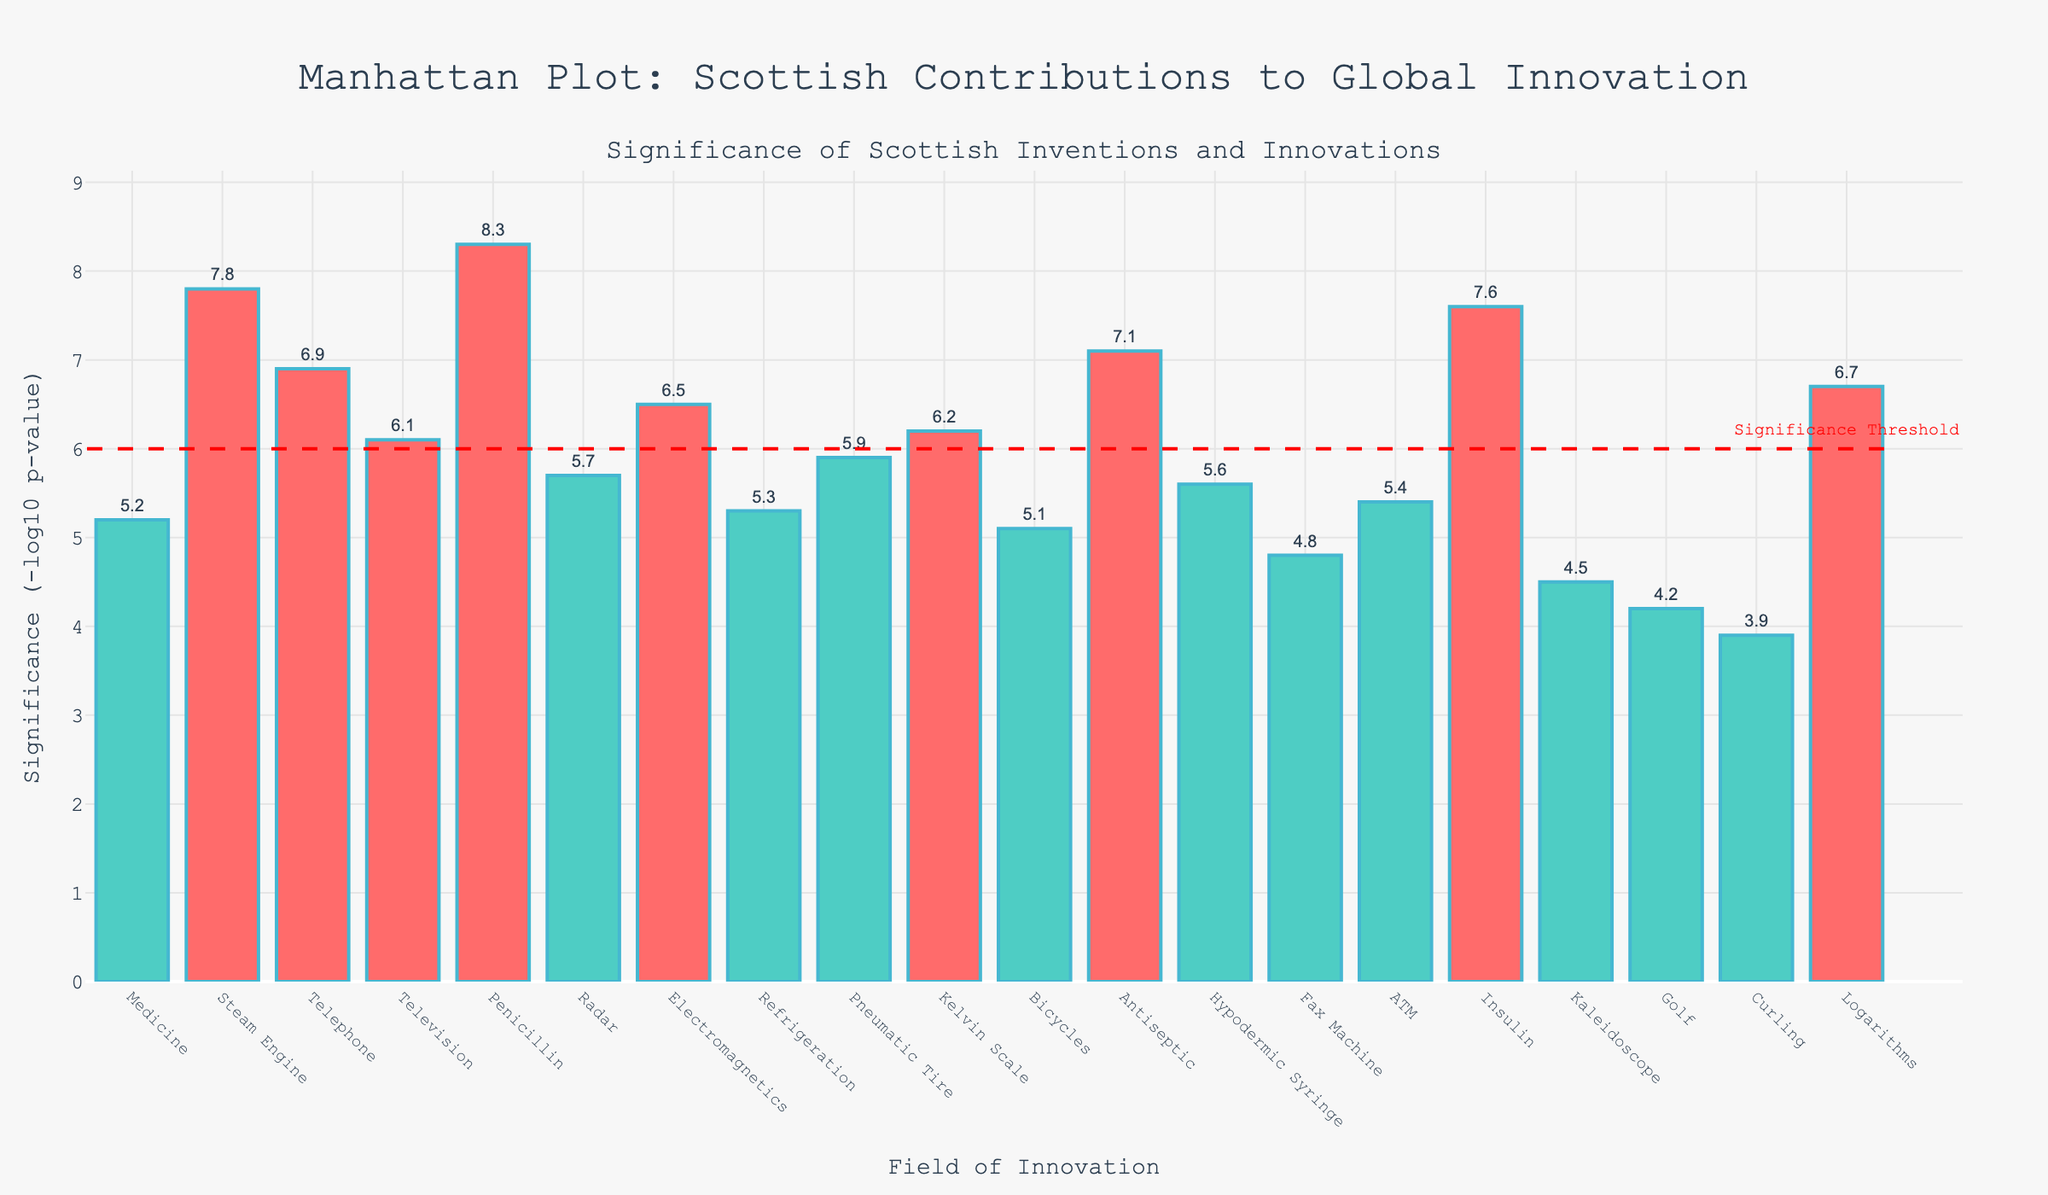How many fields have significance values above the threshold of 6? Count the bars that have LogP values above the threshold line (6) in the plot.
Answer: 10 Which field has the highest significance value? Identify the bar with the highest LogP value by checking the y-axis values.
Answer: Penicillin What is the difference in significance between the Steam Engine and the Telephone? Find the LogP values of the Steam Engine (7.8) and the Telephone (6.9), then compute the difference (7.8 - 6.9).
Answer: 0.9 How many fields have LogP values below 5? Count the bars with LogP values less than 5 on the y-axis.
Answer: 4 Which invention has a LogP value closest to 6? Compare the LogP values to see which one is nearest to 6. Electromagnetics has a LogP of 6.5, which is closest but above the threshold, and Kelvin Scale has 6.2, which is nearer and above the threshold. However, since the closest below is 5.9, we choose the nearest exceeding value.
Answer: Kelvin Scale Are there more fields with LogP values above or below the threshold of 6? Count the occurrences of bars with LogP values above and below the threshold of 6.
Answer: Above What is the title of the plot? Look at the title written at the top center of the plot.
Answer: Manhattan Plot: Scottish Contributions to Global Innovation Which has higher significance, Radar or ATM? Compare their LogP values. Radar's LogP is 5.7, while ATM's LogP is 5.4.
Answer: Radar What is the sum of LogP values of Penicillin and Insulin? Find the LogP values of Penicillin (8.3) and Insulin (7.6) and add them (8.3 + 7.6).
Answer: 15.9 What color represents fields with LogP values below 6? Check the colors of the bars with LogP values below the significance threshold line.
Answer: Green 